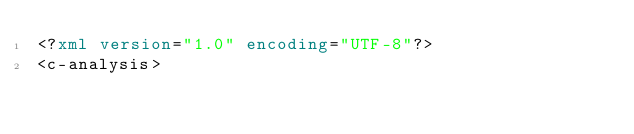Convert code to text. <code><loc_0><loc_0><loc_500><loc_500><_XML_><?xml version="1.0" encoding="UTF-8"?>
<c-analysis></code> 